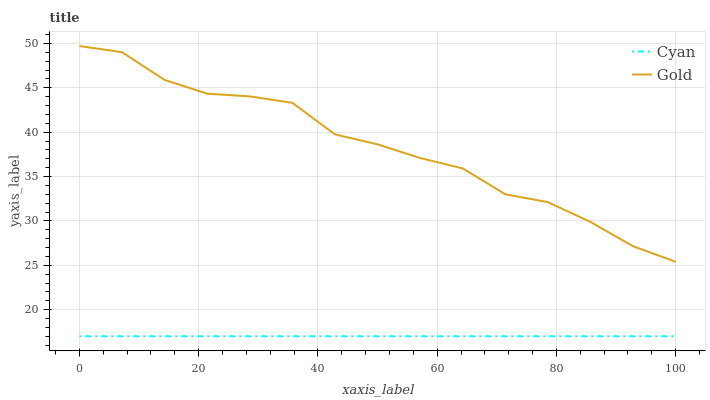Does Gold have the minimum area under the curve?
Answer yes or no. No. Is Gold the smoothest?
Answer yes or no. No. Does Gold have the lowest value?
Answer yes or no. No. Is Cyan less than Gold?
Answer yes or no. Yes. Is Gold greater than Cyan?
Answer yes or no. Yes. Does Cyan intersect Gold?
Answer yes or no. No. 